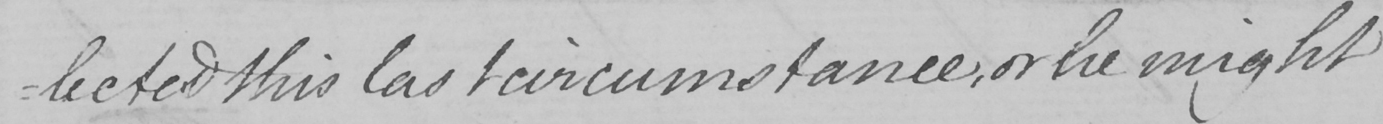What is written in this line of handwriting? : lected this last circumstance , or he might 